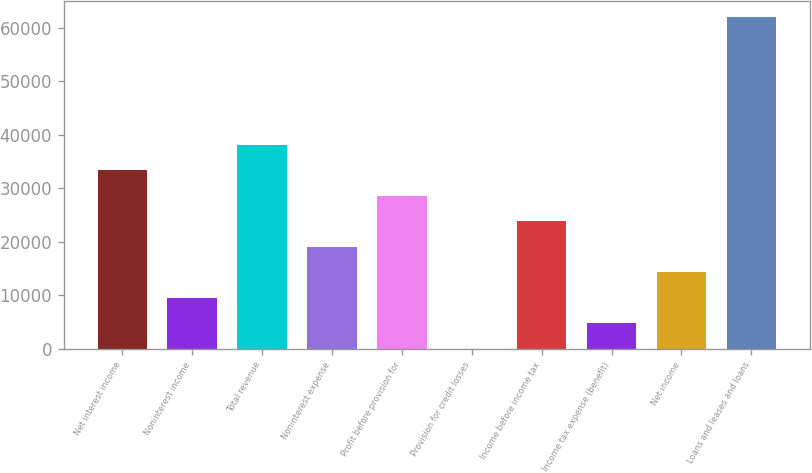Convert chart. <chart><loc_0><loc_0><loc_500><loc_500><bar_chart><fcel>Net interest income<fcel>Noninterest income<fcel>Total revenue<fcel>Noninterest expense<fcel>Profit before provision for<fcel>Provision for credit losses<fcel>Income before income tax<fcel>Income tax expense (benefit)<fcel>Net income<fcel>Loans and leases and loans<nl><fcel>33354.4<fcel>9563.4<fcel>38112.6<fcel>19079.8<fcel>28596.2<fcel>47<fcel>23838<fcel>4805.2<fcel>14321.6<fcel>61903.6<nl></chart> 